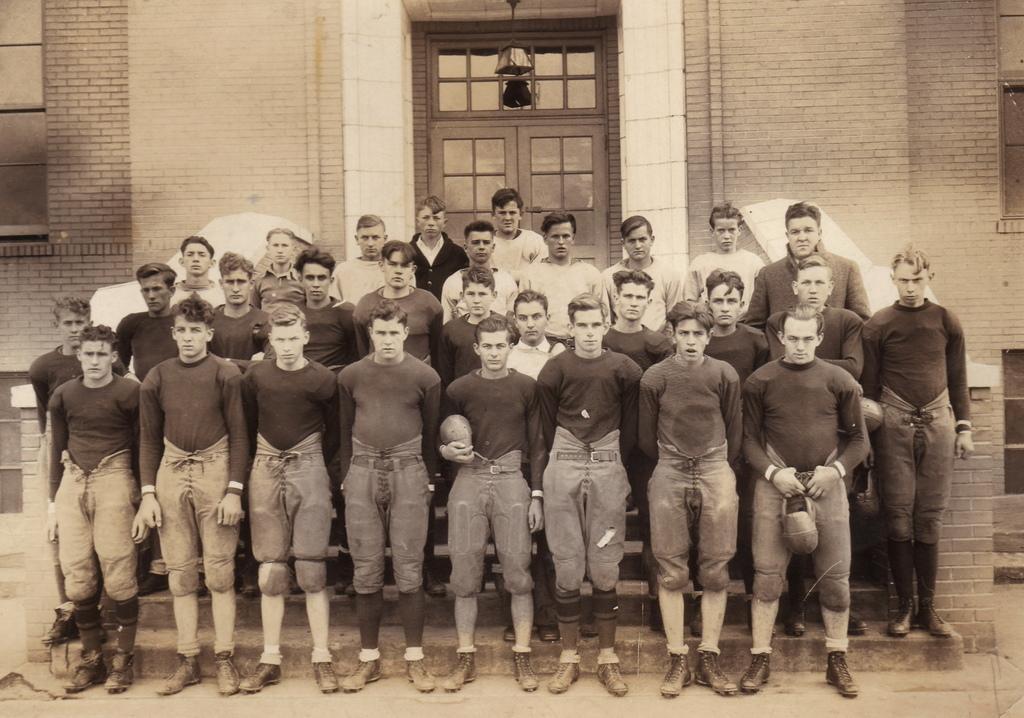Describe this image in one or two sentences. In the picture we can see a black and white photograph in it we can see a group of people standing with same dresses and in the background we can see a wall with a door. 